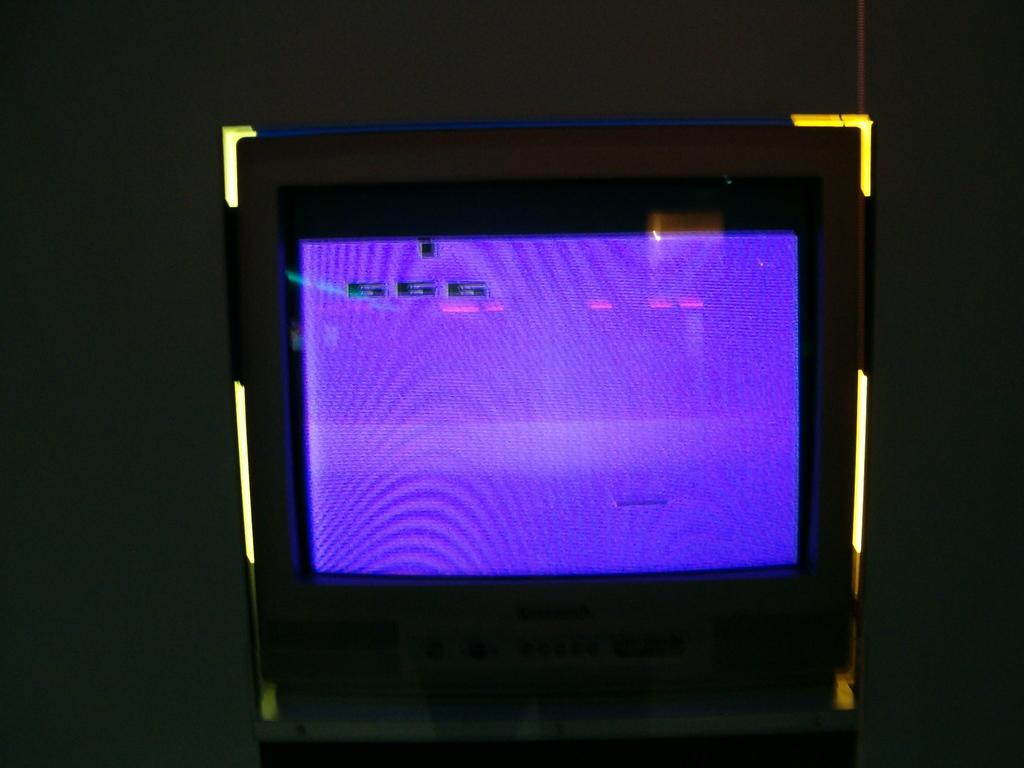Provide a one-sentence caption for the provided image. The number 666 is displayed on a video screen that's colored light purple. 